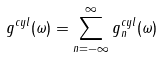<formula> <loc_0><loc_0><loc_500><loc_500>g ^ { c y l } ( \omega ) = \sum _ { n = - \infty } ^ { \infty } g ^ { c y l } _ { n } ( \omega )</formula> 